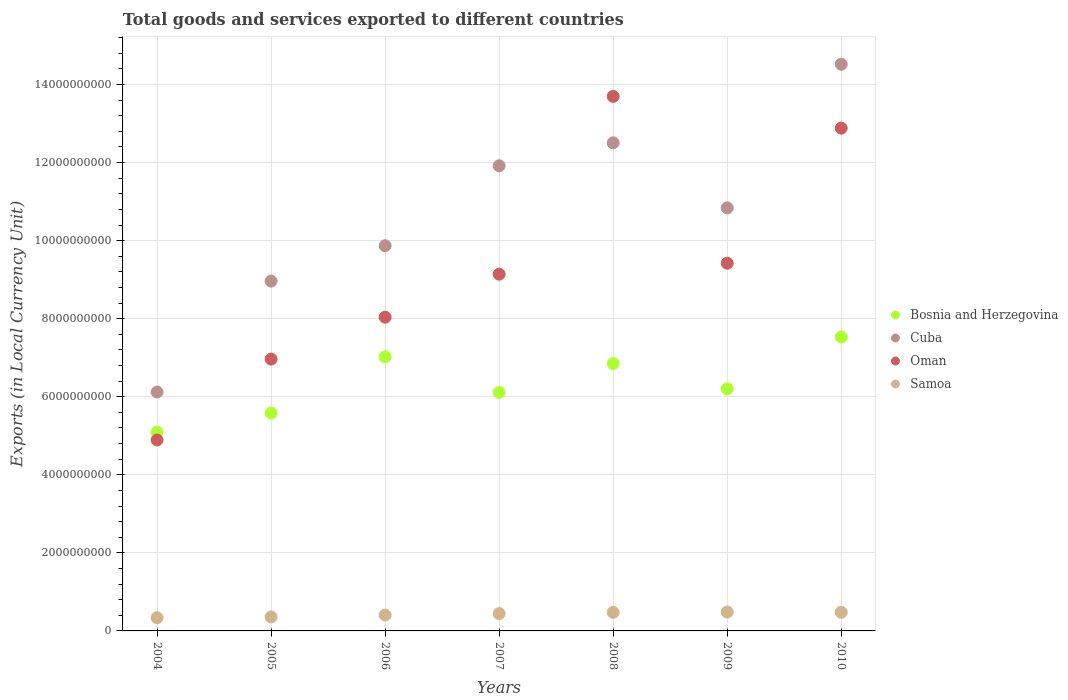Is the number of dotlines equal to the number of legend labels?
Make the answer very short. Yes. What is the Amount of goods and services exports in Samoa in 2007?
Offer a very short reply. 4.44e+08. Across all years, what is the maximum Amount of goods and services exports in Samoa?
Provide a succinct answer. 4.83e+08. Across all years, what is the minimum Amount of goods and services exports in Samoa?
Provide a succinct answer. 3.39e+08. What is the total Amount of goods and services exports in Cuba in the graph?
Ensure brevity in your answer.  7.47e+1. What is the difference between the Amount of goods and services exports in Samoa in 2005 and that in 2006?
Keep it short and to the point. -4.83e+07. What is the difference between the Amount of goods and services exports in Cuba in 2005 and the Amount of goods and services exports in Oman in 2008?
Ensure brevity in your answer.  -4.73e+09. What is the average Amount of goods and services exports in Samoa per year?
Your answer should be compact. 4.26e+08. In the year 2004, what is the difference between the Amount of goods and services exports in Oman and Amount of goods and services exports in Bosnia and Herzegovina?
Give a very brief answer. -1.98e+08. In how many years, is the Amount of goods and services exports in Cuba greater than 2400000000 LCU?
Provide a succinct answer. 7. What is the ratio of the Amount of goods and services exports in Samoa in 2007 to that in 2009?
Offer a very short reply. 0.92. What is the difference between the highest and the second highest Amount of goods and services exports in Bosnia and Herzegovina?
Your answer should be compact. 5.08e+08. What is the difference between the highest and the lowest Amount of goods and services exports in Oman?
Make the answer very short. 8.80e+09. In how many years, is the Amount of goods and services exports in Oman greater than the average Amount of goods and services exports in Oman taken over all years?
Ensure brevity in your answer.  3. Is it the case that in every year, the sum of the Amount of goods and services exports in Bosnia and Herzegovina and Amount of goods and services exports in Samoa  is greater than the sum of Amount of goods and services exports in Cuba and Amount of goods and services exports in Oman?
Keep it short and to the point. No. Is the Amount of goods and services exports in Bosnia and Herzegovina strictly less than the Amount of goods and services exports in Cuba over the years?
Your response must be concise. Yes. How many years are there in the graph?
Give a very brief answer. 7. Are the values on the major ticks of Y-axis written in scientific E-notation?
Your answer should be very brief. No. Does the graph contain any zero values?
Your response must be concise. No. Does the graph contain grids?
Your response must be concise. Yes. Where does the legend appear in the graph?
Keep it short and to the point. Center right. How are the legend labels stacked?
Provide a short and direct response. Vertical. What is the title of the graph?
Offer a very short reply. Total goods and services exported to different countries. Does "Middle East & North Africa (developing only)" appear as one of the legend labels in the graph?
Keep it short and to the point. No. What is the label or title of the X-axis?
Give a very brief answer. Years. What is the label or title of the Y-axis?
Offer a terse response. Exports (in Local Currency Unit). What is the Exports (in Local Currency Unit) of Bosnia and Herzegovina in 2004?
Provide a succinct answer. 5.09e+09. What is the Exports (in Local Currency Unit) in Cuba in 2004?
Give a very brief answer. 6.12e+09. What is the Exports (in Local Currency Unit) in Oman in 2004?
Your answer should be compact. 4.89e+09. What is the Exports (in Local Currency Unit) of Samoa in 2004?
Provide a succinct answer. 3.39e+08. What is the Exports (in Local Currency Unit) in Bosnia and Herzegovina in 2005?
Your answer should be very brief. 5.58e+09. What is the Exports (in Local Currency Unit) of Cuba in 2005?
Ensure brevity in your answer.  8.96e+09. What is the Exports (in Local Currency Unit) of Oman in 2005?
Your answer should be compact. 6.96e+09. What is the Exports (in Local Currency Unit) in Samoa in 2005?
Make the answer very short. 3.58e+08. What is the Exports (in Local Currency Unit) in Bosnia and Herzegovina in 2006?
Offer a very short reply. 7.02e+09. What is the Exports (in Local Currency Unit) of Cuba in 2006?
Ensure brevity in your answer.  9.87e+09. What is the Exports (in Local Currency Unit) in Oman in 2006?
Give a very brief answer. 8.04e+09. What is the Exports (in Local Currency Unit) in Samoa in 2006?
Your response must be concise. 4.07e+08. What is the Exports (in Local Currency Unit) in Bosnia and Herzegovina in 2007?
Keep it short and to the point. 6.11e+09. What is the Exports (in Local Currency Unit) in Cuba in 2007?
Your answer should be very brief. 1.19e+1. What is the Exports (in Local Currency Unit) of Oman in 2007?
Ensure brevity in your answer.  9.14e+09. What is the Exports (in Local Currency Unit) of Samoa in 2007?
Your answer should be compact. 4.44e+08. What is the Exports (in Local Currency Unit) of Bosnia and Herzegovina in 2008?
Give a very brief answer. 6.85e+09. What is the Exports (in Local Currency Unit) in Cuba in 2008?
Offer a very short reply. 1.25e+1. What is the Exports (in Local Currency Unit) of Oman in 2008?
Your response must be concise. 1.37e+1. What is the Exports (in Local Currency Unit) of Samoa in 2008?
Give a very brief answer. 4.74e+08. What is the Exports (in Local Currency Unit) of Bosnia and Herzegovina in 2009?
Your answer should be compact. 6.20e+09. What is the Exports (in Local Currency Unit) of Cuba in 2009?
Give a very brief answer. 1.08e+1. What is the Exports (in Local Currency Unit) of Oman in 2009?
Give a very brief answer. 9.42e+09. What is the Exports (in Local Currency Unit) in Samoa in 2009?
Provide a short and direct response. 4.83e+08. What is the Exports (in Local Currency Unit) of Bosnia and Herzegovina in 2010?
Offer a very short reply. 7.53e+09. What is the Exports (in Local Currency Unit) of Cuba in 2010?
Your answer should be very brief. 1.45e+1. What is the Exports (in Local Currency Unit) in Oman in 2010?
Keep it short and to the point. 1.29e+1. What is the Exports (in Local Currency Unit) of Samoa in 2010?
Ensure brevity in your answer.  4.77e+08. Across all years, what is the maximum Exports (in Local Currency Unit) of Bosnia and Herzegovina?
Make the answer very short. 7.53e+09. Across all years, what is the maximum Exports (in Local Currency Unit) of Cuba?
Provide a succinct answer. 1.45e+1. Across all years, what is the maximum Exports (in Local Currency Unit) of Oman?
Make the answer very short. 1.37e+1. Across all years, what is the maximum Exports (in Local Currency Unit) of Samoa?
Give a very brief answer. 4.83e+08. Across all years, what is the minimum Exports (in Local Currency Unit) in Bosnia and Herzegovina?
Your answer should be very brief. 5.09e+09. Across all years, what is the minimum Exports (in Local Currency Unit) of Cuba?
Offer a very short reply. 6.12e+09. Across all years, what is the minimum Exports (in Local Currency Unit) of Oman?
Keep it short and to the point. 4.89e+09. Across all years, what is the minimum Exports (in Local Currency Unit) of Samoa?
Your answer should be compact. 3.39e+08. What is the total Exports (in Local Currency Unit) of Bosnia and Herzegovina in the graph?
Offer a terse response. 4.44e+1. What is the total Exports (in Local Currency Unit) in Cuba in the graph?
Give a very brief answer. 7.47e+1. What is the total Exports (in Local Currency Unit) in Oman in the graph?
Your answer should be compact. 6.50e+1. What is the total Exports (in Local Currency Unit) in Samoa in the graph?
Your answer should be compact. 2.98e+09. What is the difference between the Exports (in Local Currency Unit) of Bosnia and Herzegovina in 2004 and that in 2005?
Offer a very short reply. -4.93e+08. What is the difference between the Exports (in Local Currency Unit) of Cuba in 2004 and that in 2005?
Provide a succinct answer. -2.84e+09. What is the difference between the Exports (in Local Currency Unit) of Oman in 2004 and that in 2005?
Your answer should be compact. -2.07e+09. What is the difference between the Exports (in Local Currency Unit) of Samoa in 2004 and that in 2005?
Offer a very short reply. -1.96e+07. What is the difference between the Exports (in Local Currency Unit) in Bosnia and Herzegovina in 2004 and that in 2006?
Ensure brevity in your answer.  -1.93e+09. What is the difference between the Exports (in Local Currency Unit) in Cuba in 2004 and that in 2006?
Provide a short and direct response. -3.75e+09. What is the difference between the Exports (in Local Currency Unit) of Oman in 2004 and that in 2006?
Your answer should be very brief. -3.15e+09. What is the difference between the Exports (in Local Currency Unit) of Samoa in 2004 and that in 2006?
Your answer should be compact. -6.79e+07. What is the difference between the Exports (in Local Currency Unit) in Bosnia and Herzegovina in 2004 and that in 2007?
Your answer should be very brief. -1.02e+09. What is the difference between the Exports (in Local Currency Unit) in Cuba in 2004 and that in 2007?
Offer a terse response. -5.80e+09. What is the difference between the Exports (in Local Currency Unit) in Oman in 2004 and that in 2007?
Offer a very short reply. -4.25e+09. What is the difference between the Exports (in Local Currency Unit) in Samoa in 2004 and that in 2007?
Ensure brevity in your answer.  -1.05e+08. What is the difference between the Exports (in Local Currency Unit) in Bosnia and Herzegovina in 2004 and that in 2008?
Ensure brevity in your answer.  -1.76e+09. What is the difference between the Exports (in Local Currency Unit) in Cuba in 2004 and that in 2008?
Your answer should be compact. -6.39e+09. What is the difference between the Exports (in Local Currency Unit) of Oman in 2004 and that in 2008?
Your answer should be very brief. -8.80e+09. What is the difference between the Exports (in Local Currency Unit) in Samoa in 2004 and that in 2008?
Provide a short and direct response. -1.35e+08. What is the difference between the Exports (in Local Currency Unit) of Bosnia and Herzegovina in 2004 and that in 2009?
Your answer should be compact. -1.11e+09. What is the difference between the Exports (in Local Currency Unit) in Cuba in 2004 and that in 2009?
Keep it short and to the point. -4.72e+09. What is the difference between the Exports (in Local Currency Unit) of Oman in 2004 and that in 2009?
Your answer should be very brief. -4.53e+09. What is the difference between the Exports (in Local Currency Unit) in Samoa in 2004 and that in 2009?
Ensure brevity in your answer.  -1.44e+08. What is the difference between the Exports (in Local Currency Unit) of Bosnia and Herzegovina in 2004 and that in 2010?
Your response must be concise. -2.44e+09. What is the difference between the Exports (in Local Currency Unit) in Cuba in 2004 and that in 2010?
Your answer should be very brief. -8.40e+09. What is the difference between the Exports (in Local Currency Unit) in Oman in 2004 and that in 2010?
Your answer should be very brief. -7.99e+09. What is the difference between the Exports (in Local Currency Unit) in Samoa in 2004 and that in 2010?
Offer a terse response. -1.38e+08. What is the difference between the Exports (in Local Currency Unit) of Bosnia and Herzegovina in 2005 and that in 2006?
Give a very brief answer. -1.44e+09. What is the difference between the Exports (in Local Currency Unit) of Cuba in 2005 and that in 2006?
Keep it short and to the point. -9.07e+08. What is the difference between the Exports (in Local Currency Unit) in Oman in 2005 and that in 2006?
Your answer should be very brief. -1.07e+09. What is the difference between the Exports (in Local Currency Unit) of Samoa in 2005 and that in 2006?
Your response must be concise. -4.83e+07. What is the difference between the Exports (in Local Currency Unit) in Bosnia and Herzegovina in 2005 and that in 2007?
Provide a succinct answer. -5.28e+08. What is the difference between the Exports (in Local Currency Unit) of Cuba in 2005 and that in 2007?
Provide a succinct answer. -2.96e+09. What is the difference between the Exports (in Local Currency Unit) in Oman in 2005 and that in 2007?
Ensure brevity in your answer.  -2.18e+09. What is the difference between the Exports (in Local Currency Unit) in Samoa in 2005 and that in 2007?
Provide a short and direct response. -8.52e+07. What is the difference between the Exports (in Local Currency Unit) in Bosnia and Herzegovina in 2005 and that in 2008?
Provide a succinct answer. -1.27e+09. What is the difference between the Exports (in Local Currency Unit) in Cuba in 2005 and that in 2008?
Provide a short and direct response. -3.54e+09. What is the difference between the Exports (in Local Currency Unit) of Oman in 2005 and that in 2008?
Make the answer very short. -6.73e+09. What is the difference between the Exports (in Local Currency Unit) in Samoa in 2005 and that in 2008?
Keep it short and to the point. -1.15e+08. What is the difference between the Exports (in Local Currency Unit) in Bosnia and Herzegovina in 2005 and that in 2009?
Give a very brief answer. -6.19e+08. What is the difference between the Exports (in Local Currency Unit) of Cuba in 2005 and that in 2009?
Your answer should be compact. -1.88e+09. What is the difference between the Exports (in Local Currency Unit) in Oman in 2005 and that in 2009?
Offer a terse response. -2.46e+09. What is the difference between the Exports (in Local Currency Unit) of Samoa in 2005 and that in 2009?
Keep it short and to the point. -1.25e+08. What is the difference between the Exports (in Local Currency Unit) of Bosnia and Herzegovina in 2005 and that in 2010?
Provide a short and direct response. -1.95e+09. What is the difference between the Exports (in Local Currency Unit) of Cuba in 2005 and that in 2010?
Provide a short and direct response. -5.56e+09. What is the difference between the Exports (in Local Currency Unit) of Oman in 2005 and that in 2010?
Make the answer very short. -5.92e+09. What is the difference between the Exports (in Local Currency Unit) of Samoa in 2005 and that in 2010?
Keep it short and to the point. -1.18e+08. What is the difference between the Exports (in Local Currency Unit) in Bosnia and Herzegovina in 2006 and that in 2007?
Offer a terse response. 9.14e+08. What is the difference between the Exports (in Local Currency Unit) of Cuba in 2006 and that in 2007?
Ensure brevity in your answer.  -2.05e+09. What is the difference between the Exports (in Local Currency Unit) in Oman in 2006 and that in 2007?
Your response must be concise. -1.10e+09. What is the difference between the Exports (in Local Currency Unit) in Samoa in 2006 and that in 2007?
Make the answer very short. -3.69e+07. What is the difference between the Exports (in Local Currency Unit) of Bosnia and Herzegovina in 2006 and that in 2008?
Give a very brief answer. 1.73e+08. What is the difference between the Exports (in Local Currency Unit) of Cuba in 2006 and that in 2008?
Your answer should be compact. -2.64e+09. What is the difference between the Exports (in Local Currency Unit) of Oman in 2006 and that in 2008?
Your answer should be very brief. -5.66e+09. What is the difference between the Exports (in Local Currency Unit) of Samoa in 2006 and that in 2008?
Provide a short and direct response. -6.71e+07. What is the difference between the Exports (in Local Currency Unit) of Bosnia and Herzegovina in 2006 and that in 2009?
Make the answer very short. 8.22e+08. What is the difference between the Exports (in Local Currency Unit) of Cuba in 2006 and that in 2009?
Provide a short and direct response. -9.69e+08. What is the difference between the Exports (in Local Currency Unit) of Oman in 2006 and that in 2009?
Make the answer very short. -1.38e+09. What is the difference between the Exports (in Local Currency Unit) in Samoa in 2006 and that in 2009?
Offer a terse response. -7.65e+07. What is the difference between the Exports (in Local Currency Unit) of Bosnia and Herzegovina in 2006 and that in 2010?
Give a very brief answer. -5.08e+08. What is the difference between the Exports (in Local Currency Unit) of Cuba in 2006 and that in 2010?
Provide a succinct answer. -4.65e+09. What is the difference between the Exports (in Local Currency Unit) in Oman in 2006 and that in 2010?
Offer a very short reply. -4.84e+09. What is the difference between the Exports (in Local Currency Unit) in Samoa in 2006 and that in 2010?
Keep it short and to the point. -7.01e+07. What is the difference between the Exports (in Local Currency Unit) in Bosnia and Herzegovina in 2007 and that in 2008?
Make the answer very short. -7.41e+08. What is the difference between the Exports (in Local Currency Unit) in Cuba in 2007 and that in 2008?
Your response must be concise. -5.88e+08. What is the difference between the Exports (in Local Currency Unit) in Oman in 2007 and that in 2008?
Provide a short and direct response. -4.56e+09. What is the difference between the Exports (in Local Currency Unit) in Samoa in 2007 and that in 2008?
Give a very brief answer. -3.02e+07. What is the difference between the Exports (in Local Currency Unit) in Bosnia and Herzegovina in 2007 and that in 2009?
Give a very brief answer. -9.11e+07. What is the difference between the Exports (in Local Currency Unit) in Cuba in 2007 and that in 2009?
Give a very brief answer. 1.08e+09. What is the difference between the Exports (in Local Currency Unit) in Oman in 2007 and that in 2009?
Keep it short and to the point. -2.81e+08. What is the difference between the Exports (in Local Currency Unit) of Samoa in 2007 and that in 2009?
Give a very brief answer. -3.97e+07. What is the difference between the Exports (in Local Currency Unit) of Bosnia and Herzegovina in 2007 and that in 2010?
Ensure brevity in your answer.  -1.42e+09. What is the difference between the Exports (in Local Currency Unit) of Cuba in 2007 and that in 2010?
Offer a very short reply. -2.60e+09. What is the difference between the Exports (in Local Currency Unit) of Oman in 2007 and that in 2010?
Your response must be concise. -3.74e+09. What is the difference between the Exports (in Local Currency Unit) in Samoa in 2007 and that in 2010?
Offer a very short reply. -3.33e+07. What is the difference between the Exports (in Local Currency Unit) of Bosnia and Herzegovina in 2008 and that in 2009?
Offer a very short reply. 6.49e+08. What is the difference between the Exports (in Local Currency Unit) of Cuba in 2008 and that in 2009?
Your response must be concise. 1.67e+09. What is the difference between the Exports (in Local Currency Unit) of Oman in 2008 and that in 2009?
Ensure brevity in your answer.  4.27e+09. What is the difference between the Exports (in Local Currency Unit) of Samoa in 2008 and that in 2009?
Make the answer very short. -9.49e+06. What is the difference between the Exports (in Local Currency Unit) of Bosnia and Herzegovina in 2008 and that in 2010?
Your response must be concise. -6.81e+08. What is the difference between the Exports (in Local Currency Unit) of Cuba in 2008 and that in 2010?
Ensure brevity in your answer.  -2.01e+09. What is the difference between the Exports (in Local Currency Unit) in Oman in 2008 and that in 2010?
Keep it short and to the point. 8.13e+08. What is the difference between the Exports (in Local Currency Unit) in Samoa in 2008 and that in 2010?
Your response must be concise. -3.09e+06. What is the difference between the Exports (in Local Currency Unit) in Bosnia and Herzegovina in 2009 and that in 2010?
Keep it short and to the point. -1.33e+09. What is the difference between the Exports (in Local Currency Unit) in Cuba in 2009 and that in 2010?
Provide a succinct answer. -3.68e+09. What is the difference between the Exports (in Local Currency Unit) of Oman in 2009 and that in 2010?
Keep it short and to the point. -3.46e+09. What is the difference between the Exports (in Local Currency Unit) in Samoa in 2009 and that in 2010?
Make the answer very short. 6.41e+06. What is the difference between the Exports (in Local Currency Unit) of Bosnia and Herzegovina in 2004 and the Exports (in Local Currency Unit) of Cuba in 2005?
Provide a succinct answer. -3.87e+09. What is the difference between the Exports (in Local Currency Unit) in Bosnia and Herzegovina in 2004 and the Exports (in Local Currency Unit) in Oman in 2005?
Ensure brevity in your answer.  -1.88e+09. What is the difference between the Exports (in Local Currency Unit) of Bosnia and Herzegovina in 2004 and the Exports (in Local Currency Unit) of Samoa in 2005?
Provide a succinct answer. 4.73e+09. What is the difference between the Exports (in Local Currency Unit) of Cuba in 2004 and the Exports (in Local Currency Unit) of Oman in 2005?
Provide a short and direct response. -8.44e+08. What is the difference between the Exports (in Local Currency Unit) of Cuba in 2004 and the Exports (in Local Currency Unit) of Samoa in 2005?
Provide a short and direct response. 5.76e+09. What is the difference between the Exports (in Local Currency Unit) of Oman in 2004 and the Exports (in Local Currency Unit) of Samoa in 2005?
Your response must be concise. 4.53e+09. What is the difference between the Exports (in Local Currency Unit) of Bosnia and Herzegovina in 2004 and the Exports (in Local Currency Unit) of Cuba in 2006?
Your response must be concise. -4.78e+09. What is the difference between the Exports (in Local Currency Unit) of Bosnia and Herzegovina in 2004 and the Exports (in Local Currency Unit) of Oman in 2006?
Provide a succinct answer. -2.95e+09. What is the difference between the Exports (in Local Currency Unit) of Bosnia and Herzegovina in 2004 and the Exports (in Local Currency Unit) of Samoa in 2006?
Keep it short and to the point. 4.68e+09. What is the difference between the Exports (in Local Currency Unit) in Cuba in 2004 and the Exports (in Local Currency Unit) in Oman in 2006?
Your answer should be compact. -1.92e+09. What is the difference between the Exports (in Local Currency Unit) in Cuba in 2004 and the Exports (in Local Currency Unit) in Samoa in 2006?
Provide a short and direct response. 5.71e+09. What is the difference between the Exports (in Local Currency Unit) in Oman in 2004 and the Exports (in Local Currency Unit) in Samoa in 2006?
Give a very brief answer. 4.49e+09. What is the difference between the Exports (in Local Currency Unit) in Bosnia and Herzegovina in 2004 and the Exports (in Local Currency Unit) in Cuba in 2007?
Provide a short and direct response. -6.83e+09. What is the difference between the Exports (in Local Currency Unit) of Bosnia and Herzegovina in 2004 and the Exports (in Local Currency Unit) of Oman in 2007?
Your answer should be compact. -4.05e+09. What is the difference between the Exports (in Local Currency Unit) in Bosnia and Herzegovina in 2004 and the Exports (in Local Currency Unit) in Samoa in 2007?
Provide a short and direct response. 4.65e+09. What is the difference between the Exports (in Local Currency Unit) in Cuba in 2004 and the Exports (in Local Currency Unit) in Oman in 2007?
Ensure brevity in your answer.  -3.02e+09. What is the difference between the Exports (in Local Currency Unit) in Cuba in 2004 and the Exports (in Local Currency Unit) in Samoa in 2007?
Keep it short and to the point. 5.68e+09. What is the difference between the Exports (in Local Currency Unit) in Oman in 2004 and the Exports (in Local Currency Unit) in Samoa in 2007?
Provide a short and direct response. 4.45e+09. What is the difference between the Exports (in Local Currency Unit) in Bosnia and Herzegovina in 2004 and the Exports (in Local Currency Unit) in Cuba in 2008?
Offer a terse response. -7.42e+09. What is the difference between the Exports (in Local Currency Unit) in Bosnia and Herzegovina in 2004 and the Exports (in Local Currency Unit) in Oman in 2008?
Keep it short and to the point. -8.61e+09. What is the difference between the Exports (in Local Currency Unit) of Bosnia and Herzegovina in 2004 and the Exports (in Local Currency Unit) of Samoa in 2008?
Offer a very short reply. 4.62e+09. What is the difference between the Exports (in Local Currency Unit) in Cuba in 2004 and the Exports (in Local Currency Unit) in Oman in 2008?
Ensure brevity in your answer.  -7.57e+09. What is the difference between the Exports (in Local Currency Unit) of Cuba in 2004 and the Exports (in Local Currency Unit) of Samoa in 2008?
Offer a very short reply. 5.65e+09. What is the difference between the Exports (in Local Currency Unit) in Oman in 2004 and the Exports (in Local Currency Unit) in Samoa in 2008?
Provide a succinct answer. 4.42e+09. What is the difference between the Exports (in Local Currency Unit) of Bosnia and Herzegovina in 2004 and the Exports (in Local Currency Unit) of Cuba in 2009?
Keep it short and to the point. -5.75e+09. What is the difference between the Exports (in Local Currency Unit) of Bosnia and Herzegovina in 2004 and the Exports (in Local Currency Unit) of Oman in 2009?
Make the answer very short. -4.33e+09. What is the difference between the Exports (in Local Currency Unit) of Bosnia and Herzegovina in 2004 and the Exports (in Local Currency Unit) of Samoa in 2009?
Offer a terse response. 4.61e+09. What is the difference between the Exports (in Local Currency Unit) of Cuba in 2004 and the Exports (in Local Currency Unit) of Oman in 2009?
Provide a succinct answer. -3.30e+09. What is the difference between the Exports (in Local Currency Unit) in Cuba in 2004 and the Exports (in Local Currency Unit) in Samoa in 2009?
Make the answer very short. 5.64e+09. What is the difference between the Exports (in Local Currency Unit) of Oman in 2004 and the Exports (in Local Currency Unit) of Samoa in 2009?
Give a very brief answer. 4.41e+09. What is the difference between the Exports (in Local Currency Unit) of Bosnia and Herzegovina in 2004 and the Exports (in Local Currency Unit) of Cuba in 2010?
Offer a very short reply. -9.43e+09. What is the difference between the Exports (in Local Currency Unit) of Bosnia and Herzegovina in 2004 and the Exports (in Local Currency Unit) of Oman in 2010?
Ensure brevity in your answer.  -7.79e+09. What is the difference between the Exports (in Local Currency Unit) in Bosnia and Herzegovina in 2004 and the Exports (in Local Currency Unit) in Samoa in 2010?
Provide a short and direct response. 4.61e+09. What is the difference between the Exports (in Local Currency Unit) of Cuba in 2004 and the Exports (in Local Currency Unit) of Oman in 2010?
Give a very brief answer. -6.76e+09. What is the difference between the Exports (in Local Currency Unit) of Cuba in 2004 and the Exports (in Local Currency Unit) of Samoa in 2010?
Your answer should be very brief. 5.64e+09. What is the difference between the Exports (in Local Currency Unit) in Oman in 2004 and the Exports (in Local Currency Unit) in Samoa in 2010?
Provide a succinct answer. 4.42e+09. What is the difference between the Exports (in Local Currency Unit) in Bosnia and Herzegovina in 2005 and the Exports (in Local Currency Unit) in Cuba in 2006?
Keep it short and to the point. -4.29e+09. What is the difference between the Exports (in Local Currency Unit) in Bosnia and Herzegovina in 2005 and the Exports (in Local Currency Unit) in Oman in 2006?
Your answer should be very brief. -2.46e+09. What is the difference between the Exports (in Local Currency Unit) in Bosnia and Herzegovina in 2005 and the Exports (in Local Currency Unit) in Samoa in 2006?
Offer a terse response. 5.18e+09. What is the difference between the Exports (in Local Currency Unit) in Cuba in 2005 and the Exports (in Local Currency Unit) in Oman in 2006?
Provide a short and direct response. 9.25e+08. What is the difference between the Exports (in Local Currency Unit) of Cuba in 2005 and the Exports (in Local Currency Unit) of Samoa in 2006?
Offer a very short reply. 8.56e+09. What is the difference between the Exports (in Local Currency Unit) of Oman in 2005 and the Exports (in Local Currency Unit) of Samoa in 2006?
Keep it short and to the point. 6.56e+09. What is the difference between the Exports (in Local Currency Unit) in Bosnia and Herzegovina in 2005 and the Exports (in Local Currency Unit) in Cuba in 2007?
Ensure brevity in your answer.  -6.33e+09. What is the difference between the Exports (in Local Currency Unit) in Bosnia and Herzegovina in 2005 and the Exports (in Local Currency Unit) in Oman in 2007?
Offer a very short reply. -3.56e+09. What is the difference between the Exports (in Local Currency Unit) of Bosnia and Herzegovina in 2005 and the Exports (in Local Currency Unit) of Samoa in 2007?
Your answer should be compact. 5.14e+09. What is the difference between the Exports (in Local Currency Unit) in Cuba in 2005 and the Exports (in Local Currency Unit) in Oman in 2007?
Keep it short and to the point. -1.77e+08. What is the difference between the Exports (in Local Currency Unit) in Cuba in 2005 and the Exports (in Local Currency Unit) in Samoa in 2007?
Keep it short and to the point. 8.52e+09. What is the difference between the Exports (in Local Currency Unit) in Oman in 2005 and the Exports (in Local Currency Unit) in Samoa in 2007?
Your response must be concise. 6.52e+09. What is the difference between the Exports (in Local Currency Unit) in Bosnia and Herzegovina in 2005 and the Exports (in Local Currency Unit) in Cuba in 2008?
Give a very brief answer. -6.92e+09. What is the difference between the Exports (in Local Currency Unit) of Bosnia and Herzegovina in 2005 and the Exports (in Local Currency Unit) of Oman in 2008?
Provide a succinct answer. -8.11e+09. What is the difference between the Exports (in Local Currency Unit) in Bosnia and Herzegovina in 2005 and the Exports (in Local Currency Unit) in Samoa in 2008?
Offer a terse response. 5.11e+09. What is the difference between the Exports (in Local Currency Unit) of Cuba in 2005 and the Exports (in Local Currency Unit) of Oman in 2008?
Offer a terse response. -4.73e+09. What is the difference between the Exports (in Local Currency Unit) of Cuba in 2005 and the Exports (in Local Currency Unit) of Samoa in 2008?
Make the answer very short. 8.49e+09. What is the difference between the Exports (in Local Currency Unit) of Oman in 2005 and the Exports (in Local Currency Unit) of Samoa in 2008?
Provide a succinct answer. 6.49e+09. What is the difference between the Exports (in Local Currency Unit) of Bosnia and Herzegovina in 2005 and the Exports (in Local Currency Unit) of Cuba in 2009?
Ensure brevity in your answer.  -5.26e+09. What is the difference between the Exports (in Local Currency Unit) in Bosnia and Herzegovina in 2005 and the Exports (in Local Currency Unit) in Oman in 2009?
Provide a short and direct response. -3.84e+09. What is the difference between the Exports (in Local Currency Unit) of Bosnia and Herzegovina in 2005 and the Exports (in Local Currency Unit) of Samoa in 2009?
Your response must be concise. 5.10e+09. What is the difference between the Exports (in Local Currency Unit) in Cuba in 2005 and the Exports (in Local Currency Unit) in Oman in 2009?
Offer a very short reply. -4.58e+08. What is the difference between the Exports (in Local Currency Unit) in Cuba in 2005 and the Exports (in Local Currency Unit) in Samoa in 2009?
Your response must be concise. 8.48e+09. What is the difference between the Exports (in Local Currency Unit) of Oman in 2005 and the Exports (in Local Currency Unit) of Samoa in 2009?
Offer a very short reply. 6.48e+09. What is the difference between the Exports (in Local Currency Unit) of Bosnia and Herzegovina in 2005 and the Exports (in Local Currency Unit) of Cuba in 2010?
Provide a short and direct response. -8.94e+09. What is the difference between the Exports (in Local Currency Unit) of Bosnia and Herzegovina in 2005 and the Exports (in Local Currency Unit) of Oman in 2010?
Your response must be concise. -7.30e+09. What is the difference between the Exports (in Local Currency Unit) in Bosnia and Herzegovina in 2005 and the Exports (in Local Currency Unit) in Samoa in 2010?
Keep it short and to the point. 5.11e+09. What is the difference between the Exports (in Local Currency Unit) in Cuba in 2005 and the Exports (in Local Currency Unit) in Oman in 2010?
Your answer should be compact. -3.92e+09. What is the difference between the Exports (in Local Currency Unit) of Cuba in 2005 and the Exports (in Local Currency Unit) of Samoa in 2010?
Your answer should be compact. 8.49e+09. What is the difference between the Exports (in Local Currency Unit) in Oman in 2005 and the Exports (in Local Currency Unit) in Samoa in 2010?
Offer a very short reply. 6.49e+09. What is the difference between the Exports (in Local Currency Unit) in Bosnia and Herzegovina in 2006 and the Exports (in Local Currency Unit) in Cuba in 2007?
Ensure brevity in your answer.  -4.89e+09. What is the difference between the Exports (in Local Currency Unit) in Bosnia and Herzegovina in 2006 and the Exports (in Local Currency Unit) in Oman in 2007?
Provide a succinct answer. -2.12e+09. What is the difference between the Exports (in Local Currency Unit) in Bosnia and Herzegovina in 2006 and the Exports (in Local Currency Unit) in Samoa in 2007?
Make the answer very short. 6.58e+09. What is the difference between the Exports (in Local Currency Unit) in Cuba in 2006 and the Exports (in Local Currency Unit) in Oman in 2007?
Give a very brief answer. 7.30e+08. What is the difference between the Exports (in Local Currency Unit) in Cuba in 2006 and the Exports (in Local Currency Unit) in Samoa in 2007?
Your answer should be compact. 9.43e+09. What is the difference between the Exports (in Local Currency Unit) of Oman in 2006 and the Exports (in Local Currency Unit) of Samoa in 2007?
Your answer should be compact. 7.59e+09. What is the difference between the Exports (in Local Currency Unit) of Bosnia and Herzegovina in 2006 and the Exports (in Local Currency Unit) of Cuba in 2008?
Provide a short and direct response. -5.48e+09. What is the difference between the Exports (in Local Currency Unit) in Bosnia and Herzegovina in 2006 and the Exports (in Local Currency Unit) in Oman in 2008?
Your answer should be very brief. -6.67e+09. What is the difference between the Exports (in Local Currency Unit) of Bosnia and Herzegovina in 2006 and the Exports (in Local Currency Unit) of Samoa in 2008?
Provide a short and direct response. 6.55e+09. What is the difference between the Exports (in Local Currency Unit) in Cuba in 2006 and the Exports (in Local Currency Unit) in Oman in 2008?
Your response must be concise. -3.83e+09. What is the difference between the Exports (in Local Currency Unit) in Cuba in 2006 and the Exports (in Local Currency Unit) in Samoa in 2008?
Give a very brief answer. 9.40e+09. What is the difference between the Exports (in Local Currency Unit) in Oman in 2006 and the Exports (in Local Currency Unit) in Samoa in 2008?
Provide a short and direct response. 7.56e+09. What is the difference between the Exports (in Local Currency Unit) in Bosnia and Herzegovina in 2006 and the Exports (in Local Currency Unit) in Cuba in 2009?
Keep it short and to the point. -3.81e+09. What is the difference between the Exports (in Local Currency Unit) in Bosnia and Herzegovina in 2006 and the Exports (in Local Currency Unit) in Oman in 2009?
Keep it short and to the point. -2.40e+09. What is the difference between the Exports (in Local Currency Unit) in Bosnia and Herzegovina in 2006 and the Exports (in Local Currency Unit) in Samoa in 2009?
Your answer should be very brief. 6.54e+09. What is the difference between the Exports (in Local Currency Unit) in Cuba in 2006 and the Exports (in Local Currency Unit) in Oman in 2009?
Your answer should be very brief. 4.49e+08. What is the difference between the Exports (in Local Currency Unit) in Cuba in 2006 and the Exports (in Local Currency Unit) in Samoa in 2009?
Offer a very short reply. 9.39e+09. What is the difference between the Exports (in Local Currency Unit) of Oman in 2006 and the Exports (in Local Currency Unit) of Samoa in 2009?
Your response must be concise. 7.55e+09. What is the difference between the Exports (in Local Currency Unit) in Bosnia and Herzegovina in 2006 and the Exports (in Local Currency Unit) in Cuba in 2010?
Give a very brief answer. -7.49e+09. What is the difference between the Exports (in Local Currency Unit) in Bosnia and Herzegovina in 2006 and the Exports (in Local Currency Unit) in Oman in 2010?
Your answer should be compact. -5.86e+09. What is the difference between the Exports (in Local Currency Unit) of Bosnia and Herzegovina in 2006 and the Exports (in Local Currency Unit) of Samoa in 2010?
Give a very brief answer. 6.55e+09. What is the difference between the Exports (in Local Currency Unit) of Cuba in 2006 and the Exports (in Local Currency Unit) of Oman in 2010?
Provide a succinct answer. -3.01e+09. What is the difference between the Exports (in Local Currency Unit) in Cuba in 2006 and the Exports (in Local Currency Unit) in Samoa in 2010?
Provide a succinct answer. 9.39e+09. What is the difference between the Exports (in Local Currency Unit) in Oman in 2006 and the Exports (in Local Currency Unit) in Samoa in 2010?
Your answer should be very brief. 7.56e+09. What is the difference between the Exports (in Local Currency Unit) of Bosnia and Herzegovina in 2007 and the Exports (in Local Currency Unit) of Cuba in 2008?
Make the answer very short. -6.40e+09. What is the difference between the Exports (in Local Currency Unit) in Bosnia and Herzegovina in 2007 and the Exports (in Local Currency Unit) in Oman in 2008?
Your answer should be very brief. -7.58e+09. What is the difference between the Exports (in Local Currency Unit) in Bosnia and Herzegovina in 2007 and the Exports (in Local Currency Unit) in Samoa in 2008?
Your answer should be compact. 5.64e+09. What is the difference between the Exports (in Local Currency Unit) in Cuba in 2007 and the Exports (in Local Currency Unit) in Oman in 2008?
Provide a succinct answer. -1.78e+09. What is the difference between the Exports (in Local Currency Unit) in Cuba in 2007 and the Exports (in Local Currency Unit) in Samoa in 2008?
Offer a terse response. 1.14e+1. What is the difference between the Exports (in Local Currency Unit) of Oman in 2007 and the Exports (in Local Currency Unit) of Samoa in 2008?
Make the answer very short. 8.67e+09. What is the difference between the Exports (in Local Currency Unit) of Bosnia and Herzegovina in 2007 and the Exports (in Local Currency Unit) of Cuba in 2009?
Offer a very short reply. -4.73e+09. What is the difference between the Exports (in Local Currency Unit) in Bosnia and Herzegovina in 2007 and the Exports (in Local Currency Unit) in Oman in 2009?
Make the answer very short. -3.31e+09. What is the difference between the Exports (in Local Currency Unit) of Bosnia and Herzegovina in 2007 and the Exports (in Local Currency Unit) of Samoa in 2009?
Make the answer very short. 5.63e+09. What is the difference between the Exports (in Local Currency Unit) of Cuba in 2007 and the Exports (in Local Currency Unit) of Oman in 2009?
Give a very brief answer. 2.50e+09. What is the difference between the Exports (in Local Currency Unit) of Cuba in 2007 and the Exports (in Local Currency Unit) of Samoa in 2009?
Your answer should be compact. 1.14e+1. What is the difference between the Exports (in Local Currency Unit) in Oman in 2007 and the Exports (in Local Currency Unit) in Samoa in 2009?
Your response must be concise. 8.66e+09. What is the difference between the Exports (in Local Currency Unit) in Bosnia and Herzegovina in 2007 and the Exports (in Local Currency Unit) in Cuba in 2010?
Your answer should be very brief. -8.41e+09. What is the difference between the Exports (in Local Currency Unit) of Bosnia and Herzegovina in 2007 and the Exports (in Local Currency Unit) of Oman in 2010?
Your response must be concise. -6.77e+09. What is the difference between the Exports (in Local Currency Unit) in Bosnia and Herzegovina in 2007 and the Exports (in Local Currency Unit) in Samoa in 2010?
Make the answer very short. 5.63e+09. What is the difference between the Exports (in Local Currency Unit) in Cuba in 2007 and the Exports (in Local Currency Unit) in Oman in 2010?
Offer a very short reply. -9.64e+08. What is the difference between the Exports (in Local Currency Unit) in Cuba in 2007 and the Exports (in Local Currency Unit) in Samoa in 2010?
Keep it short and to the point. 1.14e+1. What is the difference between the Exports (in Local Currency Unit) of Oman in 2007 and the Exports (in Local Currency Unit) of Samoa in 2010?
Your response must be concise. 8.66e+09. What is the difference between the Exports (in Local Currency Unit) in Bosnia and Herzegovina in 2008 and the Exports (in Local Currency Unit) in Cuba in 2009?
Your response must be concise. -3.99e+09. What is the difference between the Exports (in Local Currency Unit) of Bosnia and Herzegovina in 2008 and the Exports (in Local Currency Unit) of Oman in 2009?
Your answer should be very brief. -2.57e+09. What is the difference between the Exports (in Local Currency Unit) in Bosnia and Herzegovina in 2008 and the Exports (in Local Currency Unit) in Samoa in 2009?
Keep it short and to the point. 6.37e+09. What is the difference between the Exports (in Local Currency Unit) in Cuba in 2008 and the Exports (in Local Currency Unit) in Oman in 2009?
Give a very brief answer. 3.09e+09. What is the difference between the Exports (in Local Currency Unit) of Cuba in 2008 and the Exports (in Local Currency Unit) of Samoa in 2009?
Keep it short and to the point. 1.20e+1. What is the difference between the Exports (in Local Currency Unit) of Oman in 2008 and the Exports (in Local Currency Unit) of Samoa in 2009?
Your response must be concise. 1.32e+1. What is the difference between the Exports (in Local Currency Unit) in Bosnia and Herzegovina in 2008 and the Exports (in Local Currency Unit) in Cuba in 2010?
Your answer should be compact. -7.67e+09. What is the difference between the Exports (in Local Currency Unit) of Bosnia and Herzegovina in 2008 and the Exports (in Local Currency Unit) of Oman in 2010?
Your answer should be compact. -6.03e+09. What is the difference between the Exports (in Local Currency Unit) of Bosnia and Herzegovina in 2008 and the Exports (in Local Currency Unit) of Samoa in 2010?
Your response must be concise. 6.37e+09. What is the difference between the Exports (in Local Currency Unit) of Cuba in 2008 and the Exports (in Local Currency Unit) of Oman in 2010?
Offer a very short reply. -3.76e+08. What is the difference between the Exports (in Local Currency Unit) of Cuba in 2008 and the Exports (in Local Currency Unit) of Samoa in 2010?
Provide a short and direct response. 1.20e+1. What is the difference between the Exports (in Local Currency Unit) in Oman in 2008 and the Exports (in Local Currency Unit) in Samoa in 2010?
Provide a short and direct response. 1.32e+1. What is the difference between the Exports (in Local Currency Unit) in Bosnia and Herzegovina in 2009 and the Exports (in Local Currency Unit) in Cuba in 2010?
Provide a succinct answer. -8.32e+09. What is the difference between the Exports (in Local Currency Unit) in Bosnia and Herzegovina in 2009 and the Exports (in Local Currency Unit) in Oman in 2010?
Your answer should be compact. -6.68e+09. What is the difference between the Exports (in Local Currency Unit) of Bosnia and Herzegovina in 2009 and the Exports (in Local Currency Unit) of Samoa in 2010?
Make the answer very short. 5.73e+09. What is the difference between the Exports (in Local Currency Unit) in Cuba in 2009 and the Exports (in Local Currency Unit) in Oman in 2010?
Keep it short and to the point. -2.04e+09. What is the difference between the Exports (in Local Currency Unit) of Cuba in 2009 and the Exports (in Local Currency Unit) of Samoa in 2010?
Your answer should be very brief. 1.04e+1. What is the difference between the Exports (in Local Currency Unit) in Oman in 2009 and the Exports (in Local Currency Unit) in Samoa in 2010?
Keep it short and to the point. 8.94e+09. What is the average Exports (in Local Currency Unit) of Bosnia and Herzegovina per year?
Make the answer very short. 6.34e+09. What is the average Exports (in Local Currency Unit) in Cuba per year?
Offer a very short reply. 1.07e+1. What is the average Exports (in Local Currency Unit) of Oman per year?
Make the answer very short. 9.29e+09. What is the average Exports (in Local Currency Unit) in Samoa per year?
Give a very brief answer. 4.26e+08. In the year 2004, what is the difference between the Exports (in Local Currency Unit) of Bosnia and Herzegovina and Exports (in Local Currency Unit) of Cuba?
Your answer should be very brief. -1.03e+09. In the year 2004, what is the difference between the Exports (in Local Currency Unit) of Bosnia and Herzegovina and Exports (in Local Currency Unit) of Oman?
Ensure brevity in your answer.  1.98e+08. In the year 2004, what is the difference between the Exports (in Local Currency Unit) of Bosnia and Herzegovina and Exports (in Local Currency Unit) of Samoa?
Your response must be concise. 4.75e+09. In the year 2004, what is the difference between the Exports (in Local Currency Unit) of Cuba and Exports (in Local Currency Unit) of Oman?
Your answer should be compact. 1.23e+09. In the year 2004, what is the difference between the Exports (in Local Currency Unit) in Cuba and Exports (in Local Currency Unit) in Samoa?
Keep it short and to the point. 5.78e+09. In the year 2004, what is the difference between the Exports (in Local Currency Unit) in Oman and Exports (in Local Currency Unit) in Samoa?
Keep it short and to the point. 4.55e+09. In the year 2005, what is the difference between the Exports (in Local Currency Unit) in Bosnia and Herzegovina and Exports (in Local Currency Unit) in Cuba?
Offer a terse response. -3.38e+09. In the year 2005, what is the difference between the Exports (in Local Currency Unit) of Bosnia and Herzegovina and Exports (in Local Currency Unit) of Oman?
Provide a succinct answer. -1.38e+09. In the year 2005, what is the difference between the Exports (in Local Currency Unit) of Bosnia and Herzegovina and Exports (in Local Currency Unit) of Samoa?
Keep it short and to the point. 5.22e+09. In the year 2005, what is the difference between the Exports (in Local Currency Unit) in Cuba and Exports (in Local Currency Unit) in Oman?
Ensure brevity in your answer.  2.00e+09. In the year 2005, what is the difference between the Exports (in Local Currency Unit) of Cuba and Exports (in Local Currency Unit) of Samoa?
Provide a succinct answer. 8.60e+09. In the year 2005, what is the difference between the Exports (in Local Currency Unit) in Oman and Exports (in Local Currency Unit) in Samoa?
Give a very brief answer. 6.61e+09. In the year 2006, what is the difference between the Exports (in Local Currency Unit) of Bosnia and Herzegovina and Exports (in Local Currency Unit) of Cuba?
Your response must be concise. -2.85e+09. In the year 2006, what is the difference between the Exports (in Local Currency Unit) of Bosnia and Herzegovina and Exports (in Local Currency Unit) of Oman?
Provide a succinct answer. -1.01e+09. In the year 2006, what is the difference between the Exports (in Local Currency Unit) of Bosnia and Herzegovina and Exports (in Local Currency Unit) of Samoa?
Offer a very short reply. 6.62e+09. In the year 2006, what is the difference between the Exports (in Local Currency Unit) of Cuba and Exports (in Local Currency Unit) of Oman?
Offer a very short reply. 1.83e+09. In the year 2006, what is the difference between the Exports (in Local Currency Unit) of Cuba and Exports (in Local Currency Unit) of Samoa?
Keep it short and to the point. 9.46e+09. In the year 2006, what is the difference between the Exports (in Local Currency Unit) in Oman and Exports (in Local Currency Unit) in Samoa?
Provide a succinct answer. 7.63e+09. In the year 2007, what is the difference between the Exports (in Local Currency Unit) of Bosnia and Herzegovina and Exports (in Local Currency Unit) of Cuba?
Your response must be concise. -5.81e+09. In the year 2007, what is the difference between the Exports (in Local Currency Unit) in Bosnia and Herzegovina and Exports (in Local Currency Unit) in Oman?
Your answer should be very brief. -3.03e+09. In the year 2007, what is the difference between the Exports (in Local Currency Unit) in Bosnia and Herzegovina and Exports (in Local Currency Unit) in Samoa?
Ensure brevity in your answer.  5.67e+09. In the year 2007, what is the difference between the Exports (in Local Currency Unit) of Cuba and Exports (in Local Currency Unit) of Oman?
Provide a succinct answer. 2.78e+09. In the year 2007, what is the difference between the Exports (in Local Currency Unit) in Cuba and Exports (in Local Currency Unit) in Samoa?
Offer a terse response. 1.15e+1. In the year 2007, what is the difference between the Exports (in Local Currency Unit) in Oman and Exports (in Local Currency Unit) in Samoa?
Make the answer very short. 8.70e+09. In the year 2008, what is the difference between the Exports (in Local Currency Unit) in Bosnia and Herzegovina and Exports (in Local Currency Unit) in Cuba?
Ensure brevity in your answer.  -5.65e+09. In the year 2008, what is the difference between the Exports (in Local Currency Unit) of Bosnia and Herzegovina and Exports (in Local Currency Unit) of Oman?
Your answer should be very brief. -6.84e+09. In the year 2008, what is the difference between the Exports (in Local Currency Unit) of Bosnia and Herzegovina and Exports (in Local Currency Unit) of Samoa?
Offer a very short reply. 6.38e+09. In the year 2008, what is the difference between the Exports (in Local Currency Unit) of Cuba and Exports (in Local Currency Unit) of Oman?
Ensure brevity in your answer.  -1.19e+09. In the year 2008, what is the difference between the Exports (in Local Currency Unit) of Cuba and Exports (in Local Currency Unit) of Samoa?
Your response must be concise. 1.20e+1. In the year 2008, what is the difference between the Exports (in Local Currency Unit) of Oman and Exports (in Local Currency Unit) of Samoa?
Your response must be concise. 1.32e+1. In the year 2009, what is the difference between the Exports (in Local Currency Unit) in Bosnia and Herzegovina and Exports (in Local Currency Unit) in Cuba?
Give a very brief answer. -4.64e+09. In the year 2009, what is the difference between the Exports (in Local Currency Unit) of Bosnia and Herzegovina and Exports (in Local Currency Unit) of Oman?
Keep it short and to the point. -3.22e+09. In the year 2009, what is the difference between the Exports (in Local Currency Unit) of Bosnia and Herzegovina and Exports (in Local Currency Unit) of Samoa?
Provide a short and direct response. 5.72e+09. In the year 2009, what is the difference between the Exports (in Local Currency Unit) in Cuba and Exports (in Local Currency Unit) in Oman?
Make the answer very short. 1.42e+09. In the year 2009, what is the difference between the Exports (in Local Currency Unit) of Cuba and Exports (in Local Currency Unit) of Samoa?
Provide a short and direct response. 1.04e+1. In the year 2009, what is the difference between the Exports (in Local Currency Unit) of Oman and Exports (in Local Currency Unit) of Samoa?
Keep it short and to the point. 8.94e+09. In the year 2010, what is the difference between the Exports (in Local Currency Unit) in Bosnia and Herzegovina and Exports (in Local Currency Unit) in Cuba?
Give a very brief answer. -6.99e+09. In the year 2010, what is the difference between the Exports (in Local Currency Unit) in Bosnia and Herzegovina and Exports (in Local Currency Unit) in Oman?
Provide a succinct answer. -5.35e+09. In the year 2010, what is the difference between the Exports (in Local Currency Unit) in Bosnia and Herzegovina and Exports (in Local Currency Unit) in Samoa?
Provide a succinct answer. 7.06e+09. In the year 2010, what is the difference between the Exports (in Local Currency Unit) in Cuba and Exports (in Local Currency Unit) in Oman?
Your answer should be very brief. 1.64e+09. In the year 2010, what is the difference between the Exports (in Local Currency Unit) of Cuba and Exports (in Local Currency Unit) of Samoa?
Provide a succinct answer. 1.40e+1. In the year 2010, what is the difference between the Exports (in Local Currency Unit) of Oman and Exports (in Local Currency Unit) of Samoa?
Offer a very short reply. 1.24e+1. What is the ratio of the Exports (in Local Currency Unit) in Bosnia and Herzegovina in 2004 to that in 2005?
Your response must be concise. 0.91. What is the ratio of the Exports (in Local Currency Unit) in Cuba in 2004 to that in 2005?
Ensure brevity in your answer.  0.68. What is the ratio of the Exports (in Local Currency Unit) of Oman in 2004 to that in 2005?
Your response must be concise. 0.7. What is the ratio of the Exports (in Local Currency Unit) in Samoa in 2004 to that in 2005?
Your answer should be compact. 0.95. What is the ratio of the Exports (in Local Currency Unit) in Bosnia and Herzegovina in 2004 to that in 2006?
Your answer should be compact. 0.72. What is the ratio of the Exports (in Local Currency Unit) of Cuba in 2004 to that in 2006?
Ensure brevity in your answer.  0.62. What is the ratio of the Exports (in Local Currency Unit) of Oman in 2004 to that in 2006?
Keep it short and to the point. 0.61. What is the ratio of the Exports (in Local Currency Unit) of Samoa in 2004 to that in 2006?
Give a very brief answer. 0.83. What is the ratio of the Exports (in Local Currency Unit) of Bosnia and Herzegovina in 2004 to that in 2007?
Keep it short and to the point. 0.83. What is the ratio of the Exports (in Local Currency Unit) in Cuba in 2004 to that in 2007?
Your response must be concise. 0.51. What is the ratio of the Exports (in Local Currency Unit) in Oman in 2004 to that in 2007?
Offer a terse response. 0.54. What is the ratio of the Exports (in Local Currency Unit) in Samoa in 2004 to that in 2007?
Your answer should be very brief. 0.76. What is the ratio of the Exports (in Local Currency Unit) in Bosnia and Herzegovina in 2004 to that in 2008?
Give a very brief answer. 0.74. What is the ratio of the Exports (in Local Currency Unit) of Cuba in 2004 to that in 2008?
Give a very brief answer. 0.49. What is the ratio of the Exports (in Local Currency Unit) in Oman in 2004 to that in 2008?
Keep it short and to the point. 0.36. What is the ratio of the Exports (in Local Currency Unit) of Samoa in 2004 to that in 2008?
Your answer should be very brief. 0.71. What is the ratio of the Exports (in Local Currency Unit) in Bosnia and Herzegovina in 2004 to that in 2009?
Provide a short and direct response. 0.82. What is the ratio of the Exports (in Local Currency Unit) of Cuba in 2004 to that in 2009?
Keep it short and to the point. 0.56. What is the ratio of the Exports (in Local Currency Unit) in Oman in 2004 to that in 2009?
Offer a very short reply. 0.52. What is the ratio of the Exports (in Local Currency Unit) in Samoa in 2004 to that in 2009?
Your answer should be compact. 0.7. What is the ratio of the Exports (in Local Currency Unit) of Bosnia and Herzegovina in 2004 to that in 2010?
Your response must be concise. 0.68. What is the ratio of the Exports (in Local Currency Unit) in Cuba in 2004 to that in 2010?
Your response must be concise. 0.42. What is the ratio of the Exports (in Local Currency Unit) of Oman in 2004 to that in 2010?
Offer a very short reply. 0.38. What is the ratio of the Exports (in Local Currency Unit) in Samoa in 2004 to that in 2010?
Ensure brevity in your answer.  0.71. What is the ratio of the Exports (in Local Currency Unit) in Bosnia and Herzegovina in 2005 to that in 2006?
Your answer should be very brief. 0.79. What is the ratio of the Exports (in Local Currency Unit) of Cuba in 2005 to that in 2006?
Make the answer very short. 0.91. What is the ratio of the Exports (in Local Currency Unit) of Oman in 2005 to that in 2006?
Your answer should be compact. 0.87. What is the ratio of the Exports (in Local Currency Unit) of Samoa in 2005 to that in 2006?
Offer a terse response. 0.88. What is the ratio of the Exports (in Local Currency Unit) of Bosnia and Herzegovina in 2005 to that in 2007?
Make the answer very short. 0.91. What is the ratio of the Exports (in Local Currency Unit) in Cuba in 2005 to that in 2007?
Your answer should be compact. 0.75. What is the ratio of the Exports (in Local Currency Unit) in Oman in 2005 to that in 2007?
Offer a very short reply. 0.76. What is the ratio of the Exports (in Local Currency Unit) of Samoa in 2005 to that in 2007?
Offer a very short reply. 0.81. What is the ratio of the Exports (in Local Currency Unit) in Bosnia and Herzegovina in 2005 to that in 2008?
Keep it short and to the point. 0.81. What is the ratio of the Exports (in Local Currency Unit) in Cuba in 2005 to that in 2008?
Ensure brevity in your answer.  0.72. What is the ratio of the Exports (in Local Currency Unit) in Oman in 2005 to that in 2008?
Provide a succinct answer. 0.51. What is the ratio of the Exports (in Local Currency Unit) in Samoa in 2005 to that in 2008?
Make the answer very short. 0.76. What is the ratio of the Exports (in Local Currency Unit) of Bosnia and Herzegovina in 2005 to that in 2009?
Your answer should be very brief. 0.9. What is the ratio of the Exports (in Local Currency Unit) in Cuba in 2005 to that in 2009?
Offer a terse response. 0.83. What is the ratio of the Exports (in Local Currency Unit) of Oman in 2005 to that in 2009?
Offer a very short reply. 0.74. What is the ratio of the Exports (in Local Currency Unit) in Samoa in 2005 to that in 2009?
Your answer should be very brief. 0.74. What is the ratio of the Exports (in Local Currency Unit) in Bosnia and Herzegovina in 2005 to that in 2010?
Your response must be concise. 0.74. What is the ratio of the Exports (in Local Currency Unit) in Cuba in 2005 to that in 2010?
Provide a succinct answer. 0.62. What is the ratio of the Exports (in Local Currency Unit) in Oman in 2005 to that in 2010?
Your answer should be compact. 0.54. What is the ratio of the Exports (in Local Currency Unit) of Samoa in 2005 to that in 2010?
Make the answer very short. 0.75. What is the ratio of the Exports (in Local Currency Unit) in Bosnia and Herzegovina in 2006 to that in 2007?
Offer a terse response. 1.15. What is the ratio of the Exports (in Local Currency Unit) in Cuba in 2006 to that in 2007?
Provide a succinct answer. 0.83. What is the ratio of the Exports (in Local Currency Unit) of Oman in 2006 to that in 2007?
Keep it short and to the point. 0.88. What is the ratio of the Exports (in Local Currency Unit) in Samoa in 2006 to that in 2007?
Provide a succinct answer. 0.92. What is the ratio of the Exports (in Local Currency Unit) in Bosnia and Herzegovina in 2006 to that in 2008?
Give a very brief answer. 1.03. What is the ratio of the Exports (in Local Currency Unit) of Cuba in 2006 to that in 2008?
Offer a very short reply. 0.79. What is the ratio of the Exports (in Local Currency Unit) of Oman in 2006 to that in 2008?
Offer a very short reply. 0.59. What is the ratio of the Exports (in Local Currency Unit) of Samoa in 2006 to that in 2008?
Provide a succinct answer. 0.86. What is the ratio of the Exports (in Local Currency Unit) of Bosnia and Herzegovina in 2006 to that in 2009?
Offer a terse response. 1.13. What is the ratio of the Exports (in Local Currency Unit) of Cuba in 2006 to that in 2009?
Your answer should be compact. 0.91. What is the ratio of the Exports (in Local Currency Unit) in Oman in 2006 to that in 2009?
Make the answer very short. 0.85. What is the ratio of the Exports (in Local Currency Unit) in Samoa in 2006 to that in 2009?
Offer a very short reply. 0.84. What is the ratio of the Exports (in Local Currency Unit) of Bosnia and Herzegovina in 2006 to that in 2010?
Make the answer very short. 0.93. What is the ratio of the Exports (in Local Currency Unit) of Cuba in 2006 to that in 2010?
Make the answer very short. 0.68. What is the ratio of the Exports (in Local Currency Unit) of Oman in 2006 to that in 2010?
Your response must be concise. 0.62. What is the ratio of the Exports (in Local Currency Unit) of Samoa in 2006 to that in 2010?
Provide a succinct answer. 0.85. What is the ratio of the Exports (in Local Currency Unit) in Bosnia and Herzegovina in 2007 to that in 2008?
Your answer should be compact. 0.89. What is the ratio of the Exports (in Local Currency Unit) in Cuba in 2007 to that in 2008?
Provide a succinct answer. 0.95. What is the ratio of the Exports (in Local Currency Unit) of Oman in 2007 to that in 2008?
Provide a short and direct response. 0.67. What is the ratio of the Exports (in Local Currency Unit) of Samoa in 2007 to that in 2008?
Make the answer very short. 0.94. What is the ratio of the Exports (in Local Currency Unit) of Cuba in 2007 to that in 2009?
Offer a terse response. 1.1. What is the ratio of the Exports (in Local Currency Unit) of Oman in 2007 to that in 2009?
Offer a terse response. 0.97. What is the ratio of the Exports (in Local Currency Unit) of Samoa in 2007 to that in 2009?
Offer a very short reply. 0.92. What is the ratio of the Exports (in Local Currency Unit) of Bosnia and Herzegovina in 2007 to that in 2010?
Ensure brevity in your answer.  0.81. What is the ratio of the Exports (in Local Currency Unit) in Cuba in 2007 to that in 2010?
Keep it short and to the point. 0.82. What is the ratio of the Exports (in Local Currency Unit) in Oman in 2007 to that in 2010?
Offer a terse response. 0.71. What is the ratio of the Exports (in Local Currency Unit) in Samoa in 2007 to that in 2010?
Provide a succinct answer. 0.93. What is the ratio of the Exports (in Local Currency Unit) of Bosnia and Herzegovina in 2008 to that in 2009?
Your answer should be very brief. 1.1. What is the ratio of the Exports (in Local Currency Unit) of Cuba in 2008 to that in 2009?
Provide a short and direct response. 1.15. What is the ratio of the Exports (in Local Currency Unit) in Oman in 2008 to that in 2009?
Provide a succinct answer. 1.45. What is the ratio of the Exports (in Local Currency Unit) in Samoa in 2008 to that in 2009?
Keep it short and to the point. 0.98. What is the ratio of the Exports (in Local Currency Unit) in Bosnia and Herzegovina in 2008 to that in 2010?
Offer a very short reply. 0.91. What is the ratio of the Exports (in Local Currency Unit) in Cuba in 2008 to that in 2010?
Offer a terse response. 0.86. What is the ratio of the Exports (in Local Currency Unit) in Oman in 2008 to that in 2010?
Make the answer very short. 1.06. What is the ratio of the Exports (in Local Currency Unit) of Samoa in 2008 to that in 2010?
Make the answer very short. 0.99. What is the ratio of the Exports (in Local Currency Unit) in Bosnia and Herzegovina in 2009 to that in 2010?
Make the answer very short. 0.82. What is the ratio of the Exports (in Local Currency Unit) in Cuba in 2009 to that in 2010?
Keep it short and to the point. 0.75. What is the ratio of the Exports (in Local Currency Unit) of Oman in 2009 to that in 2010?
Keep it short and to the point. 0.73. What is the ratio of the Exports (in Local Currency Unit) of Samoa in 2009 to that in 2010?
Your response must be concise. 1.01. What is the difference between the highest and the second highest Exports (in Local Currency Unit) in Bosnia and Herzegovina?
Ensure brevity in your answer.  5.08e+08. What is the difference between the highest and the second highest Exports (in Local Currency Unit) of Cuba?
Ensure brevity in your answer.  2.01e+09. What is the difference between the highest and the second highest Exports (in Local Currency Unit) in Oman?
Your answer should be compact. 8.13e+08. What is the difference between the highest and the second highest Exports (in Local Currency Unit) of Samoa?
Your answer should be very brief. 6.41e+06. What is the difference between the highest and the lowest Exports (in Local Currency Unit) of Bosnia and Herzegovina?
Make the answer very short. 2.44e+09. What is the difference between the highest and the lowest Exports (in Local Currency Unit) in Cuba?
Provide a succinct answer. 8.40e+09. What is the difference between the highest and the lowest Exports (in Local Currency Unit) in Oman?
Provide a succinct answer. 8.80e+09. What is the difference between the highest and the lowest Exports (in Local Currency Unit) in Samoa?
Provide a short and direct response. 1.44e+08. 